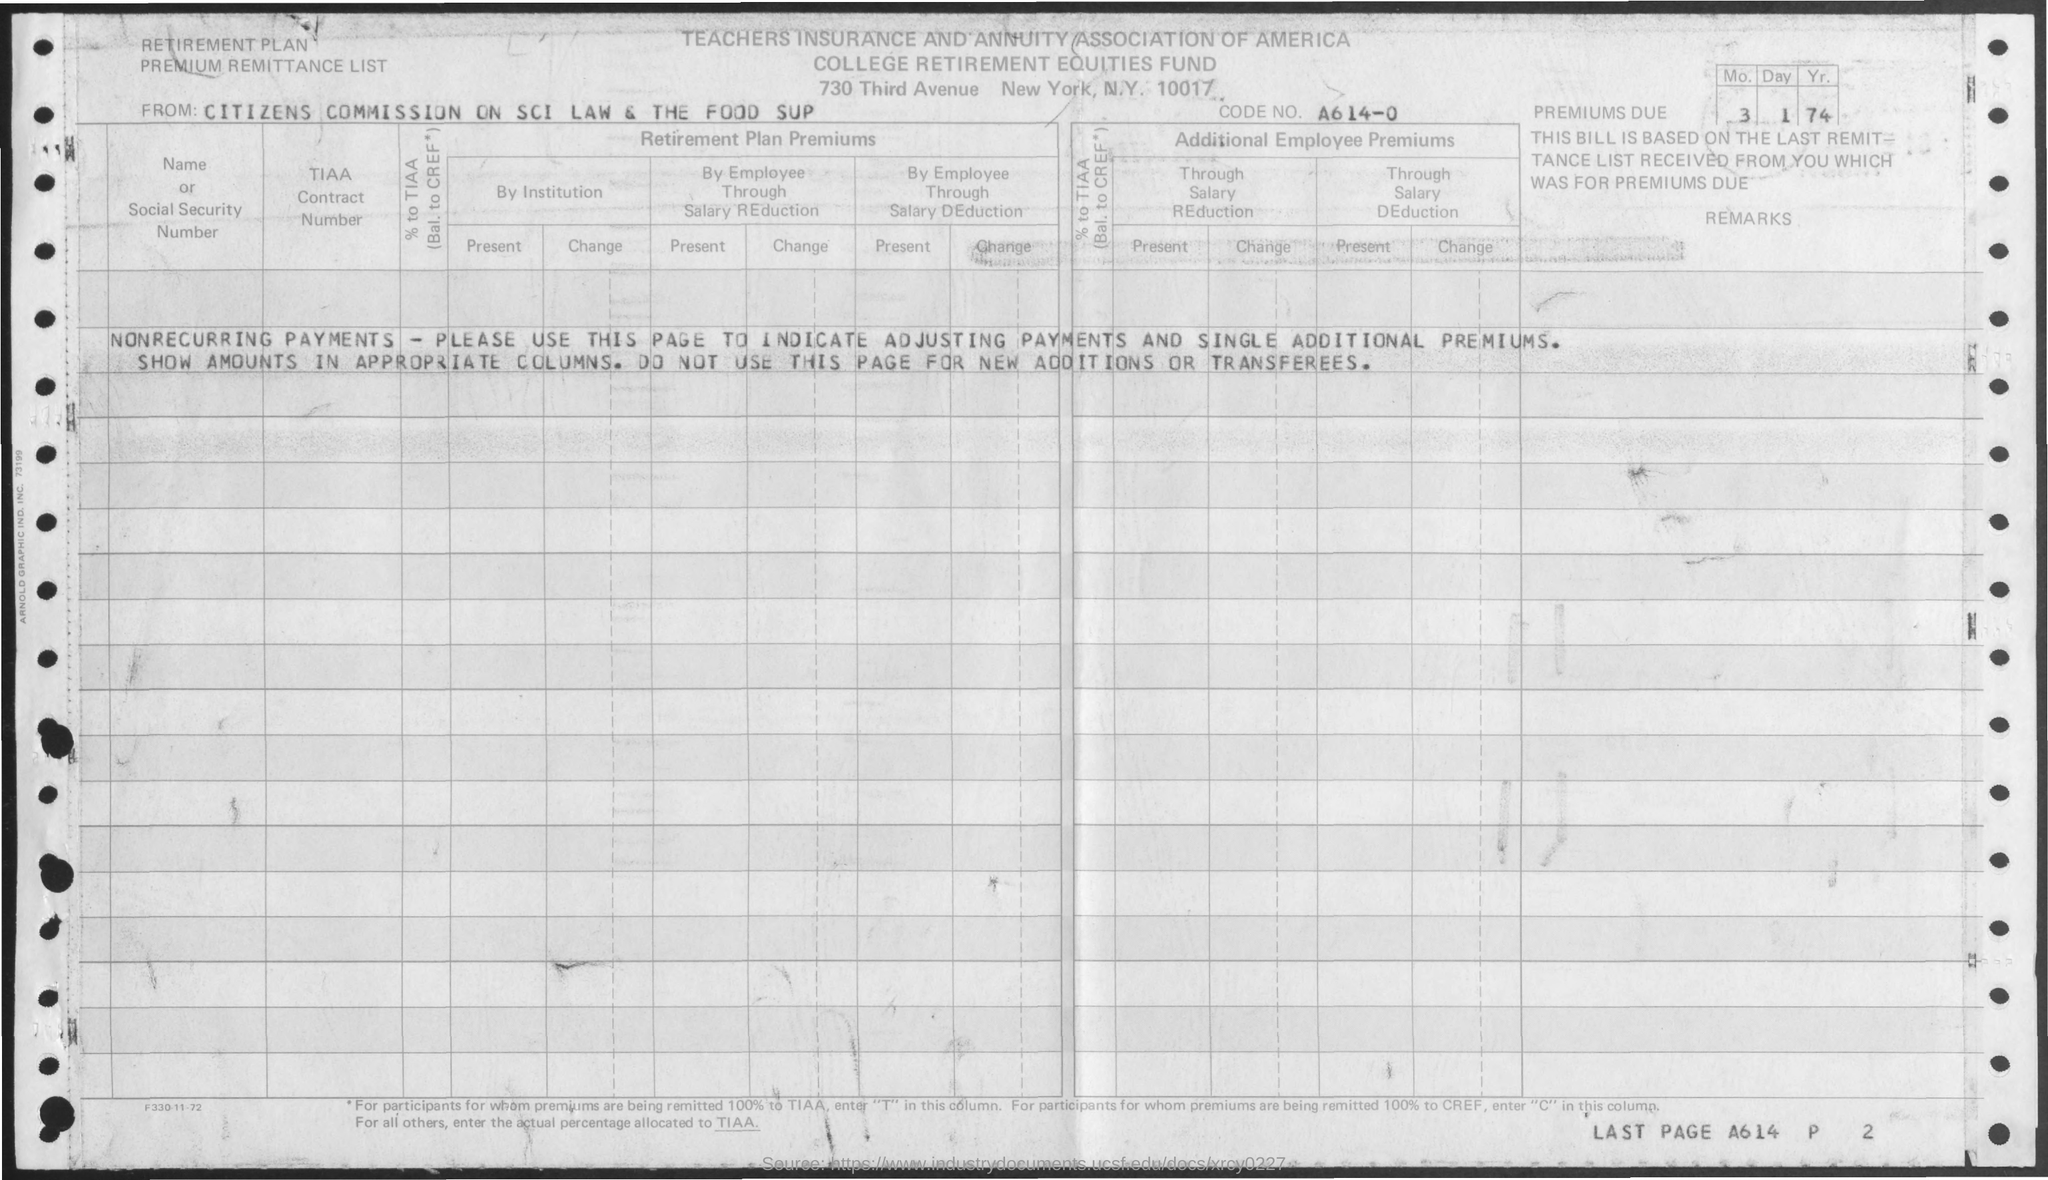Which association is mentioned?
Your response must be concise. TEACHERS INSURANCE AND ANNUITY ASSOCIATION OF AMERICA. What is the code no.?
Provide a succinct answer. A614-0. 